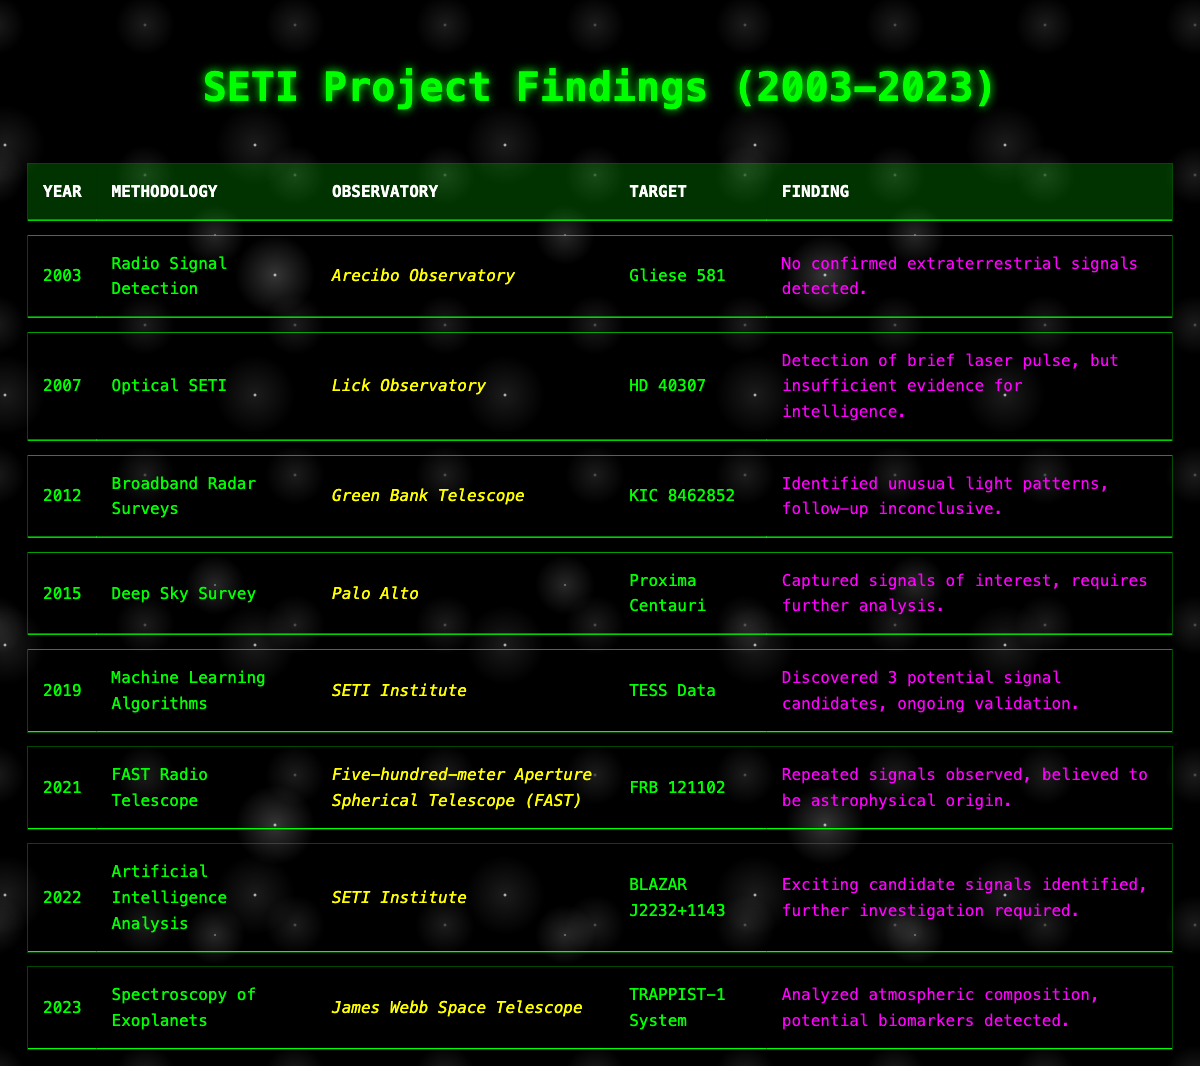What methodology was used in the 2015 SETI project finding? The 2015 finding is listed in the table under the "Year" column as 2015, with the "Methodology" column indicating "Deep Sky Survey."
Answer: Deep Sky Survey Which observatory was involved in the 2022 findings? In the table, the 2022 finding has the observatory listed as "SETI Institute."
Answer: SETI Institute How many years passed between the first radio signal detection and the detection using machine learning algorithms? The first finding was in 2003 and the machine learning findings were in 2019. Calculating the difference: 2019 - 2003 = 16 years.
Answer: 16 years Did the 2019 findings report confirmed extraterrestrial signals? The finding from 2019 stated "Discovered 3 potential signal candidates, ongoing validation," which implies no confirmed signals.
Answer: No What was the significant finding of the methodology used in 2023? The 2023 finding under "Spectroscopy of Exoplanets" indicated "Analyzed atmospheric composition, potential biomarkers detected." This points to a significant finding related to biomarkers.
Answer: Potential biomarkers detected What percentage of findings ultimately resulted in confirmed extraterrestrial signals from 2003 to 2023? Out of 8 findings listed from 2003 to 2023, none resulted in confirmed signals. Therefore, the percentage is (0/8)*100 = 0%.
Answer: 0% What was the target of the 2021 SETI project finding? In the table, the target identified in 2021 is marked as "FRB 121102."
Answer: FRB 121102 Which methodology reported a laser pulse detection? In the 2007 entry, the methodology is listed as "Optical SETI," which reported "Detection of brief laser pulse."
Answer: Optical SETI 